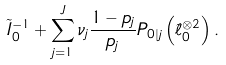<formula> <loc_0><loc_0><loc_500><loc_500>\tilde { I } _ { 0 } ^ { - 1 } + \sum _ { j = 1 } ^ { J } \nu _ { j } \frac { 1 - p _ { j } } { p _ { j } } P _ { 0 | j } \left ( \tilde { \ell } _ { 0 } ^ { \otimes 2 } \right ) .</formula> 